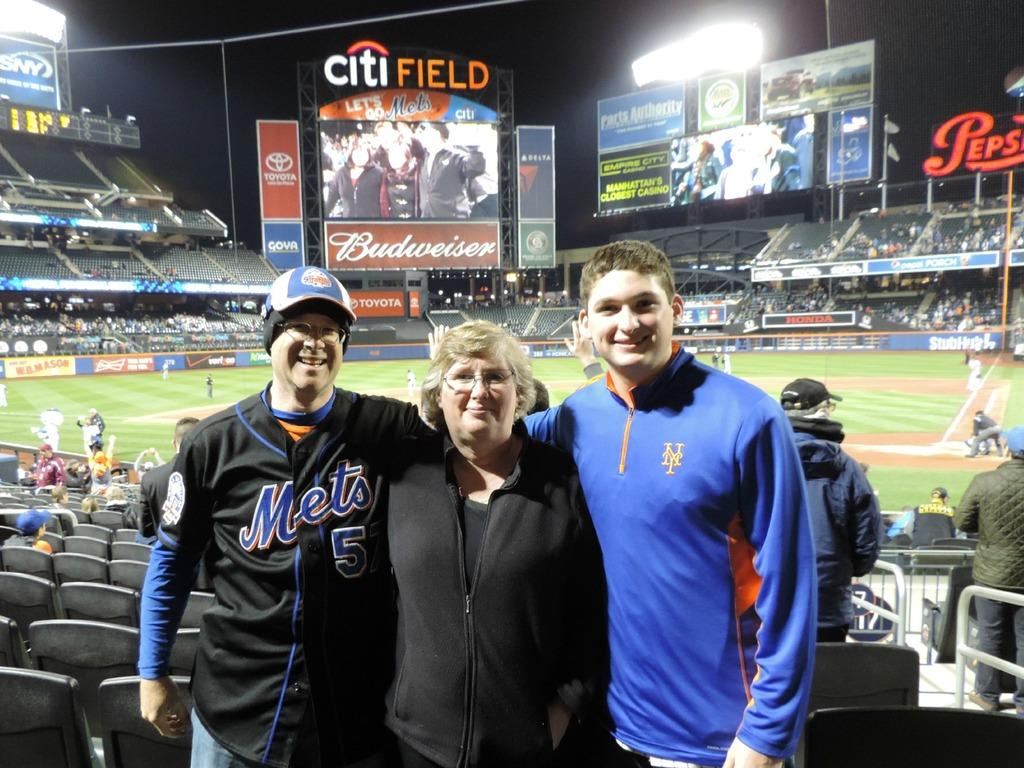Provide a one-sentence caption for the provided image. Two men and older women pose for a picture inside the City Field Baseball stadium with the TV screen in the background. 